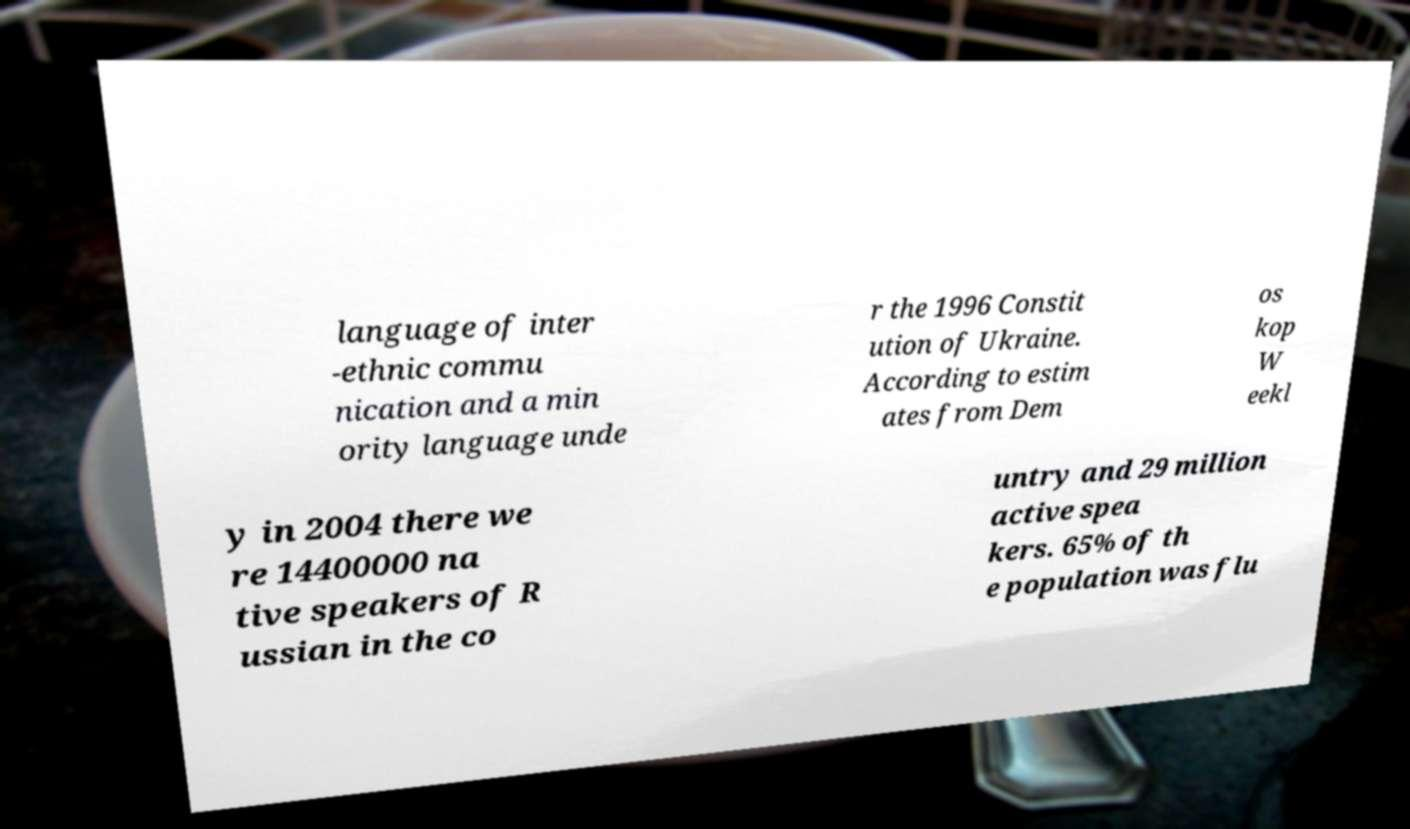I need the written content from this picture converted into text. Can you do that? language of inter -ethnic commu nication and a min ority language unde r the 1996 Constit ution of Ukraine. According to estim ates from Dem os kop W eekl y in 2004 there we re 14400000 na tive speakers of R ussian in the co untry and 29 million active spea kers. 65% of th e population was flu 